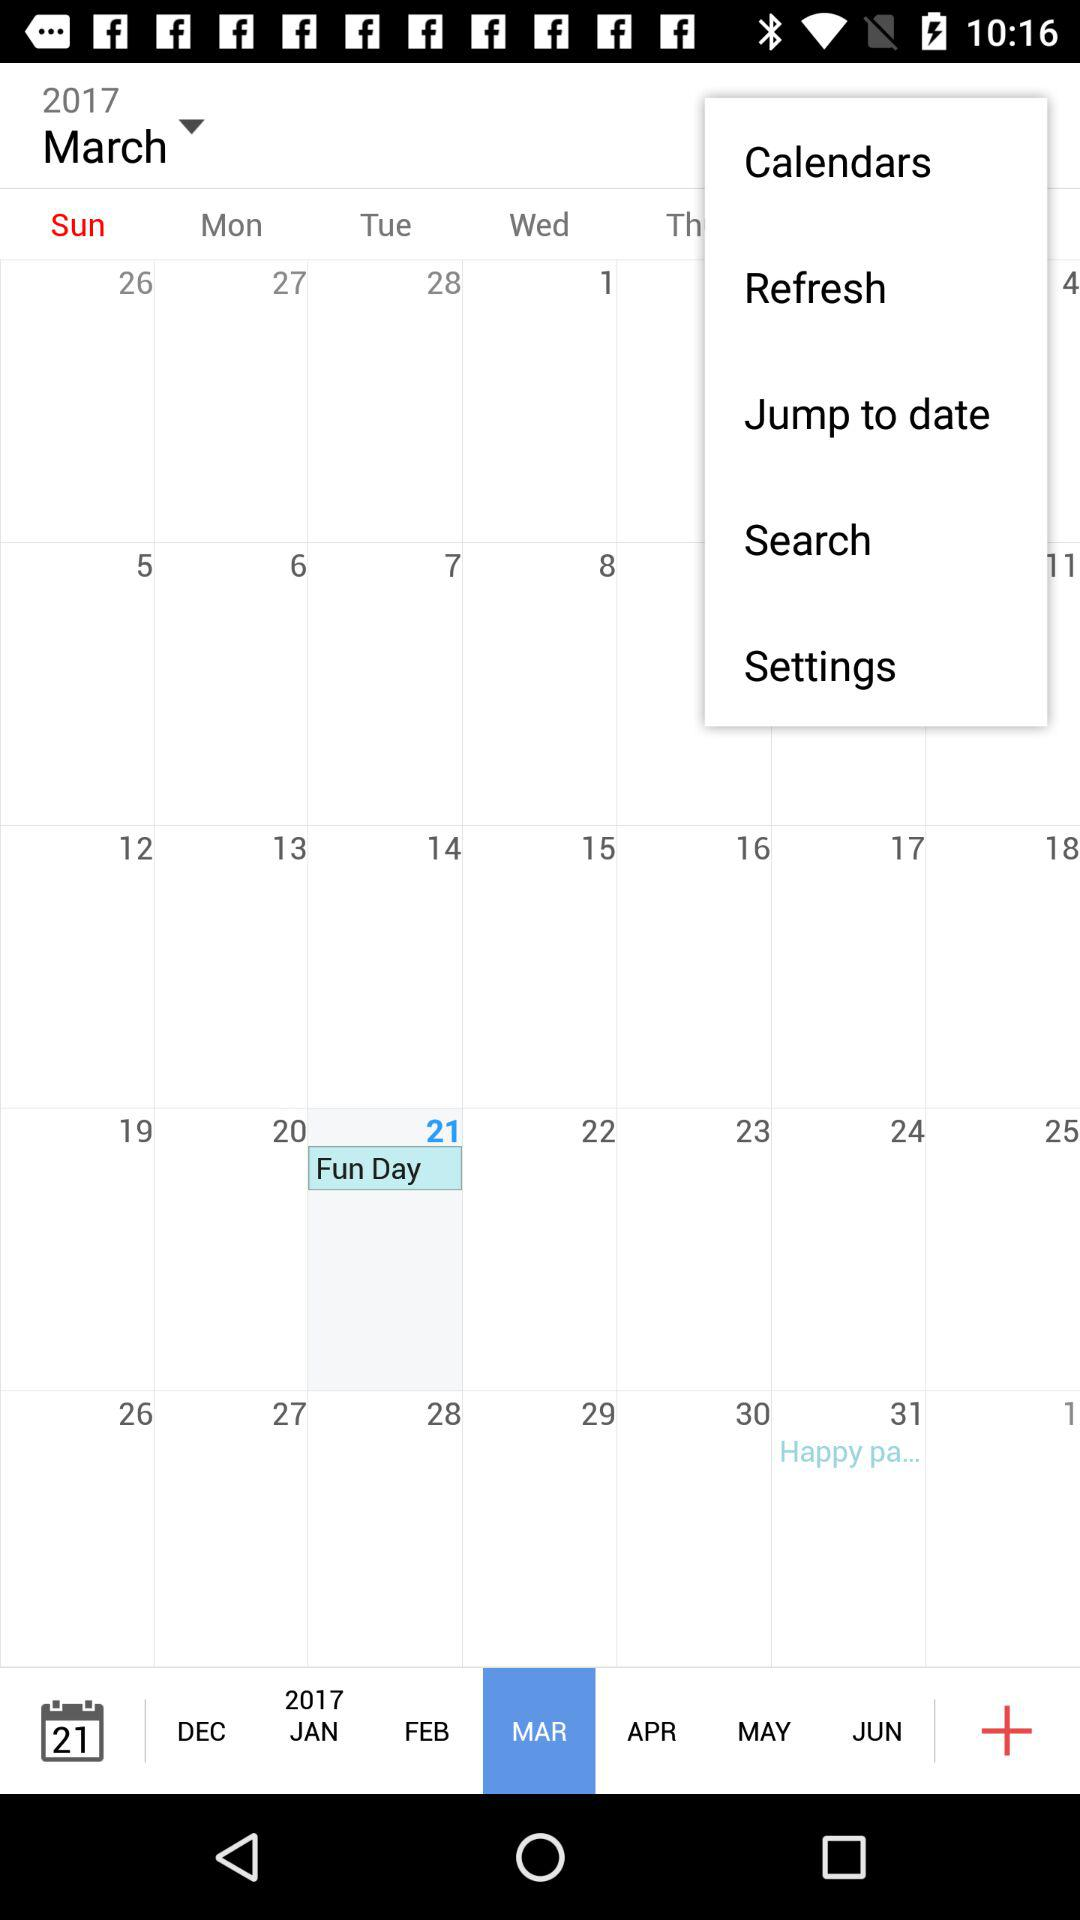What is the selected month? The selected month is March. 